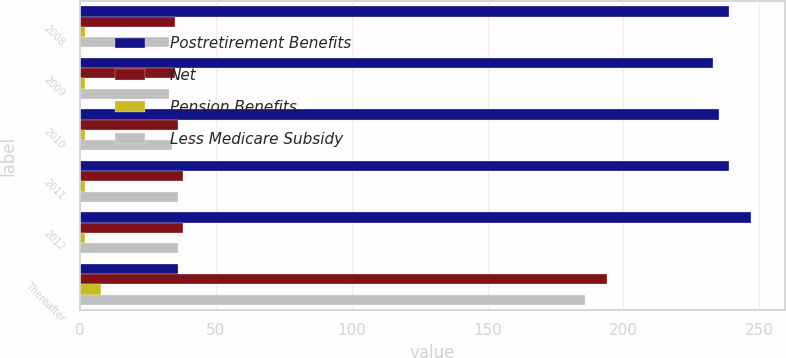Convert chart. <chart><loc_0><loc_0><loc_500><loc_500><stacked_bar_chart><ecel><fcel>2008<fcel>2009<fcel>2010<fcel>2011<fcel>2012<fcel>Thereafter<nl><fcel>Postretirement Benefits<fcel>239<fcel>233<fcel>235<fcel>239<fcel>247<fcel>36<nl><fcel>Net<fcel>35<fcel>35<fcel>36<fcel>38<fcel>38<fcel>194<nl><fcel>Pension Benefits<fcel>2<fcel>2<fcel>2<fcel>2<fcel>2<fcel>8<nl><fcel>Less Medicare Subsidy<fcel>33<fcel>33<fcel>34<fcel>36<fcel>36<fcel>186<nl></chart> 